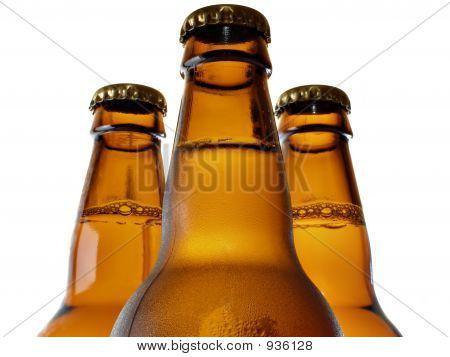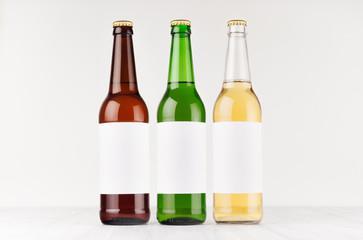The first image is the image on the left, the second image is the image on the right. Considering the images on both sides, is "The bottles in the image on the right have no caps." valid? Answer yes or no. No. 